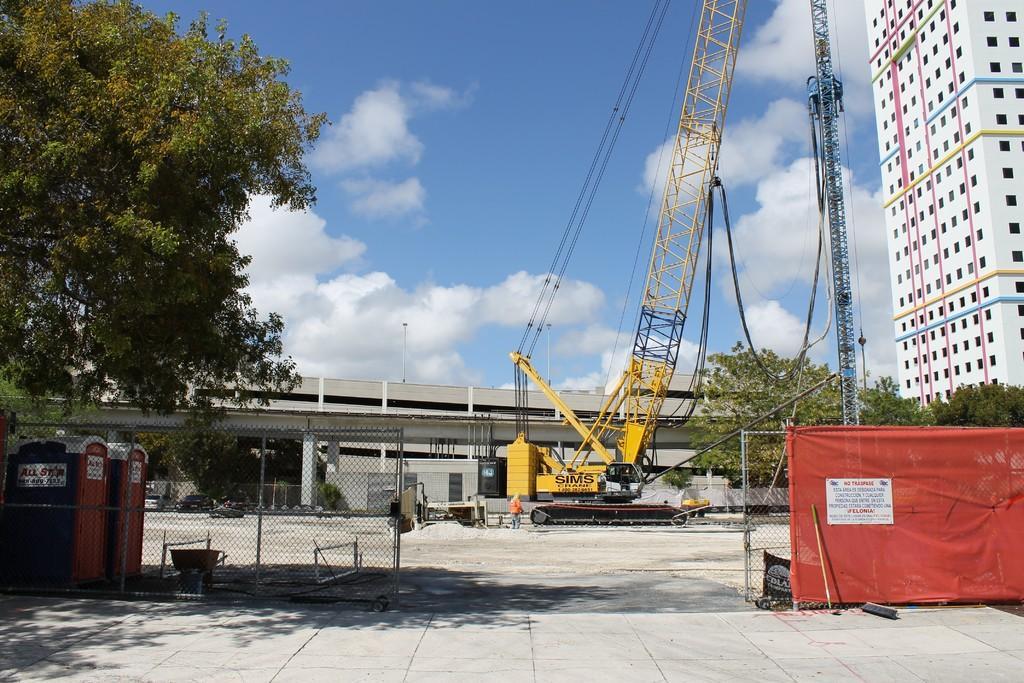In one or two sentences, can you explain what this image depicts? On the left side, there is a tree having green color leaves. On the right side, there is an orange color sheet attached to the a fence. Beside this, there is a stick, leaning on this fence. In the background, there is an excavator, there are trees, there is a bridge, there is a building which is having windows and there are clouds in the sky. 